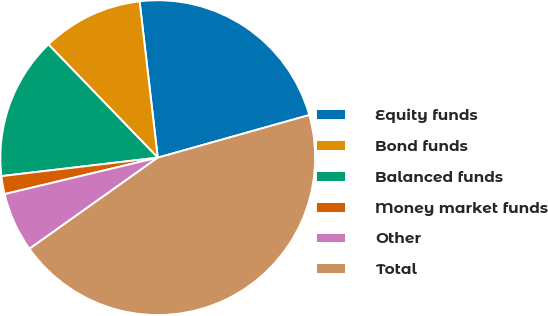<chart> <loc_0><loc_0><loc_500><loc_500><pie_chart><fcel>Equity funds<fcel>Bond funds<fcel>Balanced funds<fcel>Money market funds<fcel>Other<fcel>Total<nl><fcel>22.48%<fcel>10.38%<fcel>14.65%<fcel>1.85%<fcel>6.11%<fcel>44.53%<nl></chart> 